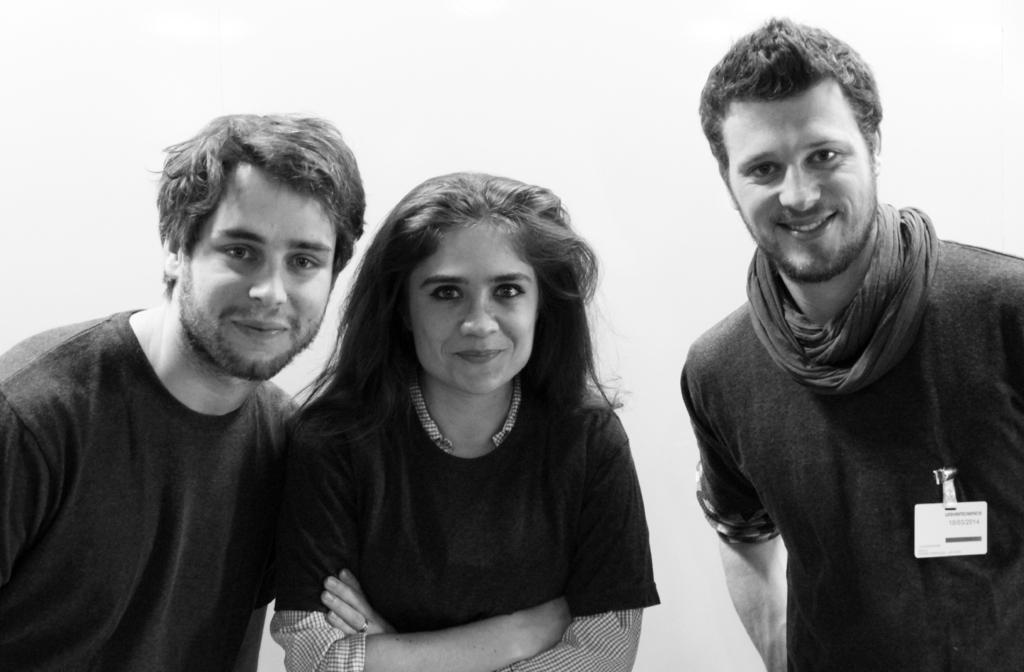How many people are in the image? There are two men and a woman in the image, making a total of three people. What is the facial expression of the individuals in the image? The individuals are smiling in the image. Can you describe any distinguishing features of the person on the right side? The person on the right side is wearing a badge. What type of scent can be detected from the image? There is no scent present in the image, as it is a visual representation and not a physical object. What is the current status of the mother in the image? There is no mention of a mother or any familial relationships in the image, so it cannot be determined. 